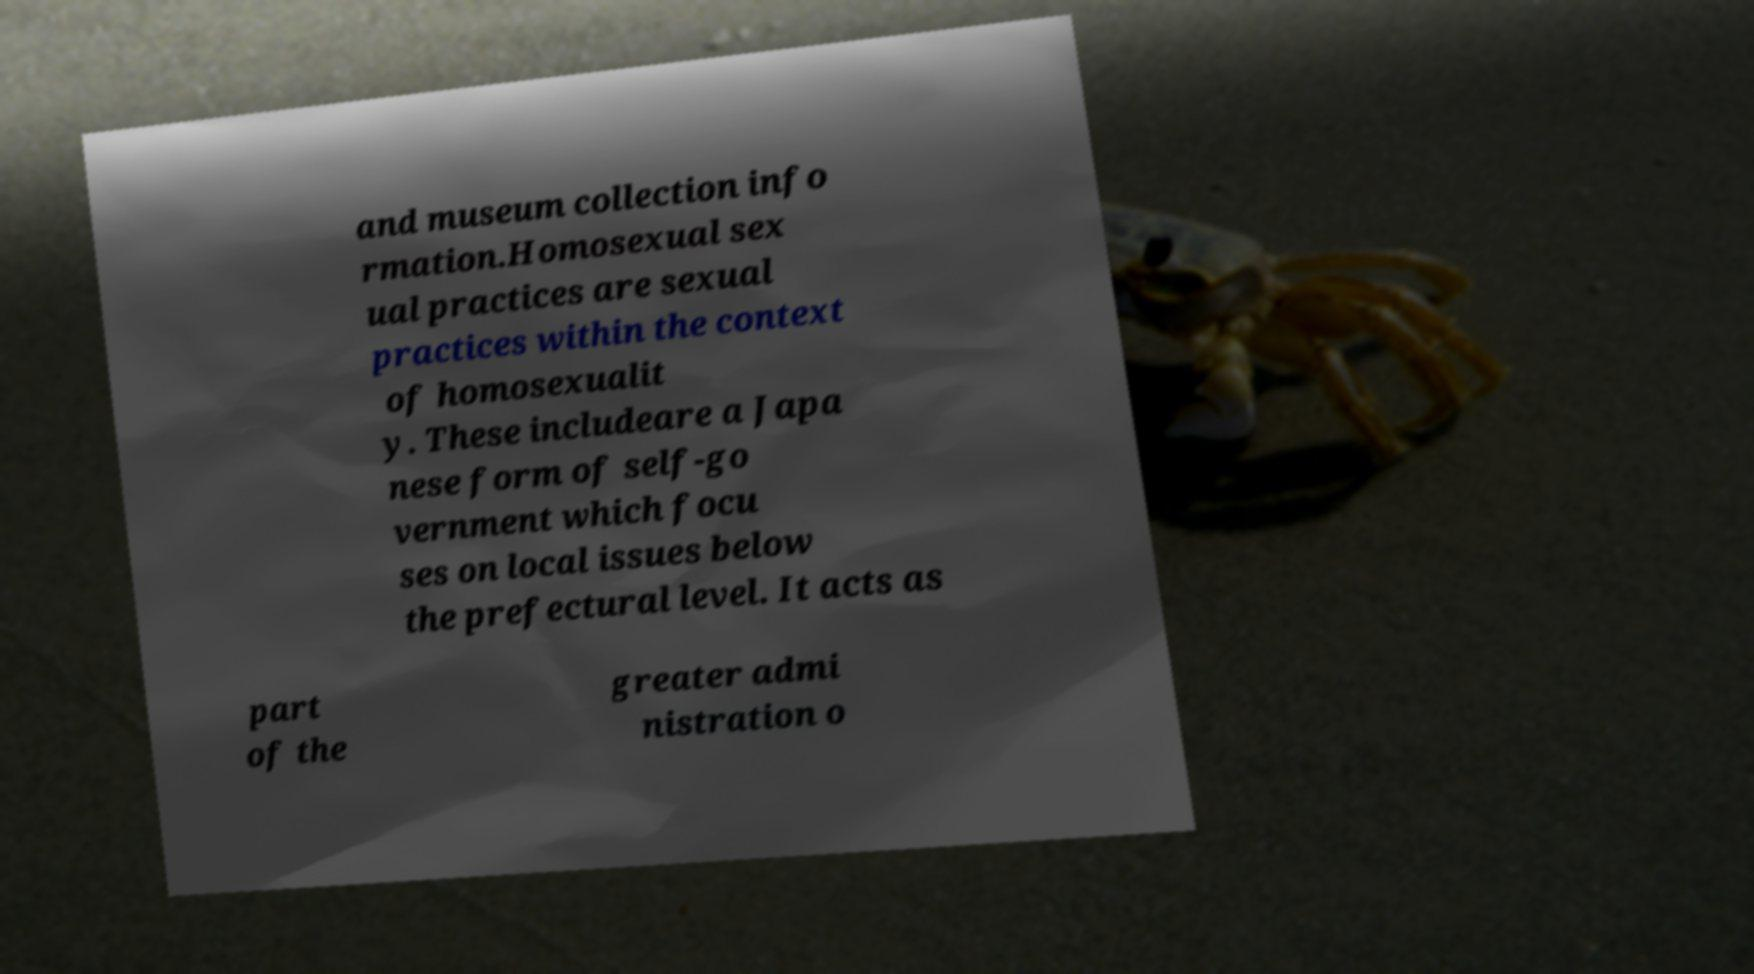There's text embedded in this image that I need extracted. Can you transcribe it verbatim? and museum collection info rmation.Homosexual sex ual practices are sexual practices within the context of homosexualit y. These includeare a Japa nese form of self-go vernment which focu ses on local issues below the prefectural level. It acts as part of the greater admi nistration o 